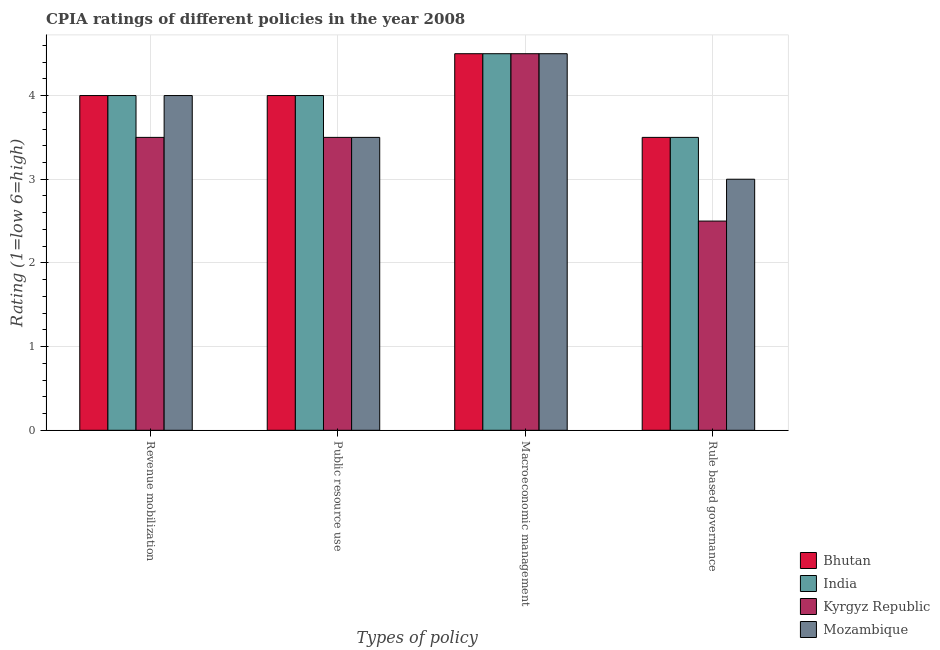How many groups of bars are there?
Offer a very short reply. 4. Are the number of bars per tick equal to the number of legend labels?
Give a very brief answer. Yes. What is the label of the 4th group of bars from the left?
Keep it short and to the point. Rule based governance. What is the cpia rating of macroeconomic management in Bhutan?
Ensure brevity in your answer.  4.5. Across all countries, what is the maximum cpia rating of macroeconomic management?
Keep it short and to the point. 4.5. Across all countries, what is the minimum cpia rating of public resource use?
Make the answer very short. 3.5. In which country was the cpia rating of revenue mobilization maximum?
Offer a terse response. Bhutan. In which country was the cpia rating of public resource use minimum?
Ensure brevity in your answer.  Kyrgyz Republic. What is the difference between the cpia rating of rule based governance in India and that in Bhutan?
Ensure brevity in your answer.  0. What is the average cpia rating of revenue mobilization per country?
Keep it short and to the point. 3.88. What is the difference between the cpia rating of macroeconomic management and cpia rating of revenue mobilization in India?
Keep it short and to the point. 0.5. What is the difference between the highest and the lowest cpia rating of macroeconomic management?
Provide a succinct answer. 0. In how many countries, is the cpia rating of public resource use greater than the average cpia rating of public resource use taken over all countries?
Your response must be concise. 2. Is the sum of the cpia rating of rule based governance in Mozambique and Kyrgyz Republic greater than the maximum cpia rating of macroeconomic management across all countries?
Offer a very short reply. Yes. Is it the case that in every country, the sum of the cpia rating of macroeconomic management and cpia rating of public resource use is greater than the sum of cpia rating of rule based governance and cpia rating of revenue mobilization?
Offer a very short reply. No. What does the 1st bar from the left in Rule based governance represents?
Ensure brevity in your answer.  Bhutan. What does the 4th bar from the right in Macroeconomic management represents?
Provide a succinct answer. Bhutan. Is it the case that in every country, the sum of the cpia rating of revenue mobilization and cpia rating of public resource use is greater than the cpia rating of macroeconomic management?
Keep it short and to the point. Yes. How many bars are there?
Make the answer very short. 16. Are all the bars in the graph horizontal?
Your answer should be compact. No. How many countries are there in the graph?
Offer a very short reply. 4. What is the difference between two consecutive major ticks on the Y-axis?
Your answer should be very brief. 1. Does the graph contain any zero values?
Offer a very short reply. No. Does the graph contain grids?
Offer a terse response. Yes. What is the title of the graph?
Offer a terse response. CPIA ratings of different policies in the year 2008. What is the label or title of the X-axis?
Make the answer very short. Types of policy. What is the label or title of the Y-axis?
Give a very brief answer. Rating (1=low 6=high). What is the Rating (1=low 6=high) in Kyrgyz Republic in Revenue mobilization?
Offer a very short reply. 3.5. What is the Rating (1=low 6=high) of Mozambique in Revenue mobilization?
Your response must be concise. 4. What is the Rating (1=low 6=high) in Kyrgyz Republic in Public resource use?
Offer a very short reply. 3.5. What is the Rating (1=low 6=high) of Kyrgyz Republic in Macroeconomic management?
Offer a terse response. 4.5. What is the Rating (1=low 6=high) in India in Rule based governance?
Offer a very short reply. 3.5. What is the Rating (1=low 6=high) in Kyrgyz Republic in Rule based governance?
Provide a succinct answer. 2.5. Across all Types of policy, what is the maximum Rating (1=low 6=high) of Bhutan?
Provide a succinct answer. 4.5. Across all Types of policy, what is the maximum Rating (1=low 6=high) in India?
Provide a succinct answer. 4.5. Across all Types of policy, what is the maximum Rating (1=low 6=high) of Kyrgyz Republic?
Provide a short and direct response. 4.5. Across all Types of policy, what is the minimum Rating (1=low 6=high) of India?
Your answer should be very brief. 3.5. Across all Types of policy, what is the minimum Rating (1=low 6=high) of Mozambique?
Offer a very short reply. 3. What is the total Rating (1=low 6=high) of Kyrgyz Republic in the graph?
Ensure brevity in your answer.  14. What is the difference between the Rating (1=low 6=high) of Bhutan in Revenue mobilization and that in Public resource use?
Your response must be concise. 0. What is the difference between the Rating (1=low 6=high) of India in Revenue mobilization and that in Public resource use?
Provide a succinct answer. 0. What is the difference between the Rating (1=low 6=high) of Bhutan in Revenue mobilization and that in Macroeconomic management?
Offer a very short reply. -0.5. What is the difference between the Rating (1=low 6=high) of Mozambique in Revenue mobilization and that in Macroeconomic management?
Keep it short and to the point. -0.5. What is the difference between the Rating (1=low 6=high) in Bhutan in Revenue mobilization and that in Rule based governance?
Your answer should be very brief. 0.5. What is the difference between the Rating (1=low 6=high) in India in Revenue mobilization and that in Rule based governance?
Offer a very short reply. 0.5. What is the difference between the Rating (1=low 6=high) of Bhutan in Public resource use and that in Macroeconomic management?
Your answer should be compact. -0.5. What is the difference between the Rating (1=low 6=high) in Kyrgyz Republic in Public resource use and that in Macroeconomic management?
Provide a short and direct response. -1. What is the difference between the Rating (1=low 6=high) in Bhutan in Public resource use and that in Rule based governance?
Ensure brevity in your answer.  0.5. What is the difference between the Rating (1=low 6=high) of India in Public resource use and that in Rule based governance?
Provide a short and direct response. 0.5. What is the difference between the Rating (1=low 6=high) of Bhutan in Macroeconomic management and that in Rule based governance?
Offer a very short reply. 1. What is the difference between the Rating (1=low 6=high) of India in Macroeconomic management and that in Rule based governance?
Your answer should be very brief. 1. What is the difference between the Rating (1=low 6=high) of Kyrgyz Republic in Macroeconomic management and that in Rule based governance?
Your answer should be very brief. 2. What is the difference between the Rating (1=low 6=high) of Mozambique in Macroeconomic management and that in Rule based governance?
Ensure brevity in your answer.  1.5. What is the difference between the Rating (1=low 6=high) of Bhutan in Revenue mobilization and the Rating (1=low 6=high) of Mozambique in Public resource use?
Offer a terse response. 0.5. What is the difference between the Rating (1=low 6=high) of India in Revenue mobilization and the Rating (1=low 6=high) of Mozambique in Public resource use?
Your answer should be compact. 0.5. What is the difference between the Rating (1=low 6=high) of Kyrgyz Republic in Revenue mobilization and the Rating (1=low 6=high) of Mozambique in Public resource use?
Ensure brevity in your answer.  0. What is the difference between the Rating (1=low 6=high) of Bhutan in Revenue mobilization and the Rating (1=low 6=high) of India in Macroeconomic management?
Give a very brief answer. -0.5. What is the difference between the Rating (1=low 6=high) of Bhutan in Revenue mobilization and the Rating (1=low 6=high) of Mozambique in Macroeconomic management?
Ensure brevity in your answer.  -0.5. What is the difference between the Rating (1=low 6=high) of India in Revenue mobilization and the Rating (1=low 6=high) of Mozambique in Macroeconomic management?
Your response must be concise. -0.5. What is the difference between the Rating (1=low 6=high) of Kyrgyz Republic in Revenue mobilization and the Rating (1=low 6=high) of Mozambique in Macroeconomic management?
Ensure brevity in your answer.  -1. What is the difference between the Rating (1=low 6=high) in Bhutan in Revenue mobilization and the Rating (1=low 6=high) in India in Rule based governance?
Your answer should be compact. 0.5. What is the difference between the Rating (1=low 6=high) in Bhutan in Revenue mobilization and the Rating (1=low 6=high) in Kyrgyz Republic in Rule based governance?
Provide a succinct answer. 1.5. What is the difference between the Rating (1=low 6=high) of Bhutan in Revenue mobilization and the Rating (1=low 6=high) of Mozambique in Rule based governance?
Keep it short and to the point. 1. What is the difference between the Rating (1=low 6=high) in Kyrgyz Republic in Revenue mobilization and the Rating (1=low 6=high) in Mozambique in Rule based governance?
Your response must be concise. 0.5. What is the difference between the Rating (1=low 6=high) in Bhutan in Public resource use and the Rating (1=low 6=high) in Kyrgyz Republic in Macroeconomic management?
Give a very brief answer. -0.5. What is the difference between the Rating (1=low 6=high) in Bhutan in Public resource use and the Rating (1=low 6=high) in Mozambique in Macroeconomic management?
Offer a terse response. -0.5. What is the difference between the Rating (1=low 6=high) of India in Public resource use and the Rating (1=low 6=high) of Kyrgyz Republic in Macroeconomic management?
Keep it short and to the point. -0.5. What is the difference between the Rating (1=low 6=high) of Kyrgyz Republic in Public resource use and the Rating (1=low 6=high) of Mozambique in Macroeconomic management?
Offer a terse response. -1. What is the difference between the Rating (1=low 6=high) of Bhutan in Public resource use and the Rating (1=low 6=high) of India in Rule based governance?
Your answer should be very brief. 0.5. What is the difference between the Rating (1=low 6=high) in Bhutan in Public resource use and the Rating (1=low 6=high) in Mozambique in Rule based governance?
Ensure brevity in your answer.  1. What is the difference between the Rating (1=low 6=high) of Kyrgyz Republic in Public resource use and the Rating (1=low 6=high) of Mozambique in Rule based governance?
Ensure brevity in your answer.  0.5. What is the difference between the Rating (1=low 6=high) in Bhutan in Macroeconomic management and the Rating (1=low 6=high) in India in Rule based governance?
Offer a terse response. 1. What is the difference between the Rating (1=low 6=high) in India in Macroeconomic management and the Rating (1=low 6=high) in Kyrgyz Republic in Rule based governance?
Offer a very short reply. 2. What is the average Rating (1=low 6=high) in Bhutan per Types of policy?
Provide a short and direct response. 4. What is the average Rating (1=low 6=high) in Mozambique per Types of policy?
Your answer should be compact. 3.75. What is the difference between the Rating (1=low 6=high) in Bhutan and Rating (1=low 6=high) in Kyrgyz Republic in Revenue mobilization?
Keep it short and to the point. 0.5. What is the difference between the Rating (1=low 6=high) in Bhutan and Rating (1=low 6=high) in Mozambique in Revenue mobilization?
Keep it short and to the point. 0. What is the difference between the Rating (1=low 6=high) of India and Rating (1=low 6=high) of Kyrgyz Republic in Revenue mobilization?
Offer a terse response. 0.5. What is the difference between the Rating (1=low 6=high) of India and Rating (1=low 6=high) of Mozambique in Revenue mobilization?
Offer a very short reply. 0. What is the difference between the Rating (1=low 6=high) in Bhutan and Rating (1=low 6=high) in India in Public resource use?
Offer a terse response. 0. What is the difference between the Rating (1=low 6=high) in India and Rating (1=low 6=high) in Mozambique in Public resource use?
Offer a terse response. 0.5. What is the difference between the Rating (1=low 6=high) in Kyrgyz Republic and Rating (1=low 6=high) in Mozambique in Public resource use?
Offer a terse response. 0. What is the difference between the Rating (1=low 6=high) of India and Rating (1=low 6=high) of Kyrgyz Republic in Macroeconomic management?
Make the answer very short. 0. What is the difference between the Rating (1=low 6=high) in India and Rating (1=low 6=high) in Mozambique in Macroeconomic management?
Your response must be concise. 0. What is the difference between the Rating (1=low 6=high) in Kyrgyz Republic and Rating (1=low 6=high) in Mozambique in Macroeconomic management?
Offer a terse response. 0. What is the difference between the Rating (1=low 6=high) of Bhutan and Rating (1=low 6=high) of India in Rule based governance?
Offer a very short reply. 0. What is the difference between the Rating (1=low 6=high) of Bhutan and Rating (1=low 6=high) of Kyrgyz Republic in Rule based governance?
Your response must be concise. 1. What is the difference between the Rating (1=low 6=high) in Bhutan and Rating (1=low 6=high) in Mozambique in Rule based governance?
Your answer should be compact. 0.5. What is the difference between the Rating (1=low 6=high) of India and Rating (1=low 6=high) of Kyrgyz Republic in Rule based governance?
Provide a short and direct response. 1. What is the difference between the Rating (1=low 6=high) of India and Rating (1=low 6=high) of Mozambique in Rule based governance?
Provide a short and direct response. 0.5. What is the difference between the Rating (1=low 6=high) in Kyrgyz Republic and Rating (1=low 6=high) in Mozambique in Rule based governance?
Your answer should be compact. -0.5. What is the ratio of the Rating (1=low 6=high) in Bhutan in Revenue mobilization to that in Public resource use?
Provide a succinct answer. 1. What is the ratio of the Rating (1=low 6=high) of India in Revenue mobilization to that in Public resource use?
Give a very brief answer. 1. What is the ratio of the Rating (1=low 6=high) of Mozambique in Revenue mobilization to that in Public resource use?
Your response must be concise. 1.14. What is the ratio of the Rating (1=low 6=high) of Bhutan in Revenue mobilization to that in Macroeconomic management?
Make the answer very short. 0.89. What is the ratio of the Rating (1=low 6=high) of Kyrgyz Republic in Revenue mobilization to that in Macroeconomic management?
Offer a terse response. 0.78. What is the ratio of the Rating (1=low 6=high) in Mozambique in Revenue mobilization to that in Macroeconomic management?
Ensure brevity in your answer.  0.89. What is the ratio of the Rating (1=low 6=high) of Mozambique in Revenue mobilization to that in Rule based governance?
Offer a very short reply. 1.33. What is the ratio of the Rating (1=low 6=high) of India in Public resource use to that in Macroeconomic management?
Offer a very short reply. 0.89. What is the ratio of the Rating (1=low 6=high) of Bhutan in Public resource use to that in Rule based governance?
Your response must be concise. 1.14. What is the ratio of the Rating (1=low 6=high) in Mozambique in Public resource use to that in Rule based governance?
Ensure brevity in your answer.  1.17. What is the ratio of the Rating (1=low 6=high) in Kyrgyz Republic in Macroeconomic management to that in Rule based governance?
Ensure brevity in your answer.  1.8. What is the ratio of the Rating (1=low 6=high) of Mozambique in Macroeconomic management to that in Rule based governance?
Keep it short and to the point. 1.5. What is the difference between the highest and the second highest Rating (1=low 6=high) in Bhutan?
Make the answer very short. 0.5. What is the difference between the highest and the second highest Rating (1=low 6=high) of Kyrgyz Republic?
Provide a short and direct response. 1. What is the difference between the highest and the lowest Rating (1=low 6=high) of Kyrgyz Republic?
Provide a short and direct response. 2. What is the difference between the highest and the lowest Rating (1=low 6=high) of Mozambique?
Provide a succinct answer. 1.5. 